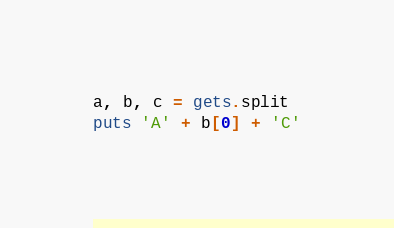Convert code to text. <code><loc_0><loc_0><loc_500><loc_500><_Ruby_>a, b, c = gets.split
puts 'A' + b[0] + 'C'</code> 